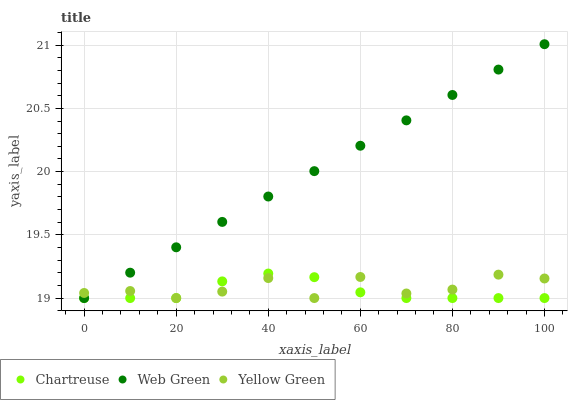Does Chartreuse have the minimum area under the curve?
Answer yes or no. Yes. Does Web Green have the maximum area under the curve?
Answer yes or no. Yes. Does Yellow Green have the minimum area under the curve?
Answer yes or no. No. Does Yellow Green have the maximum area under the curve?
Answer yes or no. No. Is Web Green the smoothest?
Answer yes or no. Yes. Is Yellow Green the roughest?
Answer yes or no. Yes. Is Yellow Green the smoothest?
Answer yes or no. No. Is Web Green the roughest?
Answer yes or no. No. Does Chartreuse have the lowest value?
Answer yes or no. Yes. Does Web Green have the highest value?
Answer yes or no. Yes. Does Yellow Green have the highest value?
Answer yes or no. No. Does Chartreuse intersect Web Green?
Answer yes or no. Yes. Is Chartreuse less than Web Green?
Answer yes or no. No. Is Chartreuse greater than Web Green?
Answer yes or no. No. 